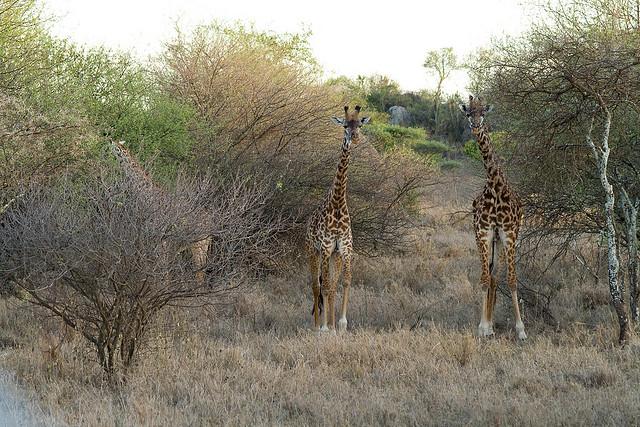Is this animal out in the wild?
Answer briefly. Yes. What kind of animal is this?
Give a very brief answer. Giraffe. Are the trees green?
Write a very short answer. No. Are the giraffes standing and eating peacefully?
Keep it brief. Yes. Are the giraffes touching each other?
Answer briefly. No. Is it winter?
Quick response, please. No. How many animals can be seen?
Answer briefly. 2. What patterns are on those animals?
Give a very brief answer. Spots. How many animals?
Write a very short answer. 2. What is cast?
Short answer required. Shadow. Are the animals in the brush?
Concise answer only. Yes. How many zebras are there?
Give a very brief answer. 0. What are the giraffes surrounded by?
Quick response, please. Trees. 